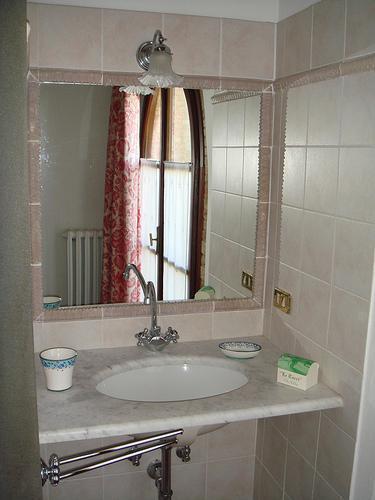How many mirrors are in the room?
Give a very brief answer. 1. How many sinks are in the picture?
Give a very brief answer. 1. How many objects are on the counter?
Give a very brief answer. 3. How many windows are visible in the photo?
Give a very brief answer. 1. 